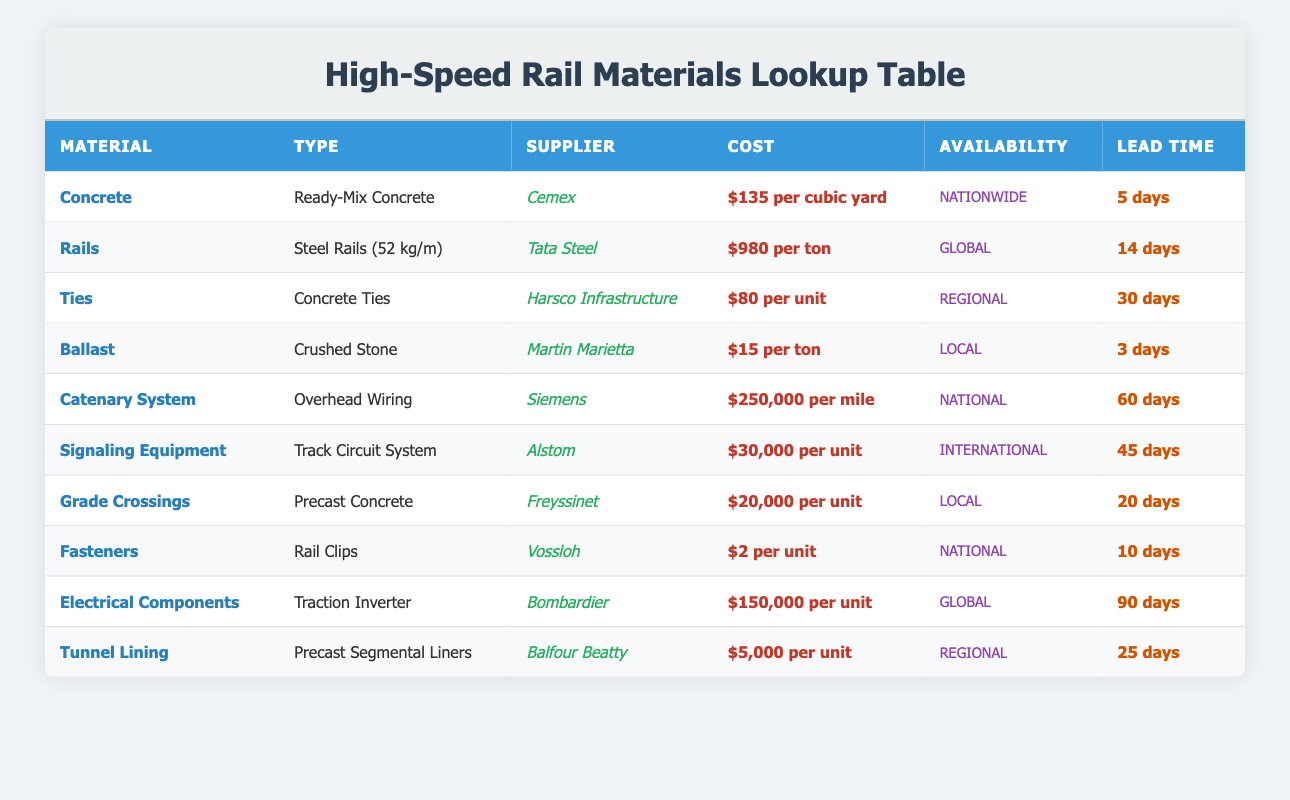What is the cost per cubic yard of Ready-Mix Concrete? The table shows that the cost for Ready-Mix Concrete from Cemex is listed as $135 per cubic yard.
Answer: $135 per cubic yard Which supplier provides Steel Rails? According to the table, the supplier for Steel Rails (52 kg/m) is Tata Steel.
Answer: Tata Steel What is the lead time for Concrete Ties? The lead time for Concrete Ties, as stated in the table, is 30 days.
Answer: 30 days How many materials have a lead time longer than 30 days? By examining the lead times in the table, the Catenary System has a lead time of 60 days and Electrical Components have a lead time of 90 days. This gives us a total of 2 materials with a lead time longer than 30 days.
Answer: 2 What is the total cost for 100 tons of Crushed Stone? The cost for Crushed Stone is $15 per ton. For 100 tons, the total cost would be calculated as 100 × 15 = $1500. Therefore, the total cost for 100 tons of Crushed Stone is $1500.
Answer: $1500 Is the supplier for Signaling Equipment local? The table indicates that the supplier for Signaling Equipment is Alstom, which is categorized as international. Therefore, it is not local.
Answer: No Which material has the longest lead time? The materials' lead times can be compared, and the longest lead time is for Electrical Components, which has 90 days as its lead time.
Answer: Electrical Components What is the total cost of purchasing 10 units of Grade Crossings? The cost for Grade Crossings is $20,000 per unit. To find the total cost for 10 units, we multiply: 10 × 20,000 = 200,000. Therefore, the total cost for 10 units is $200,000.
Answer: $200,000 Are all materials provided by suppliers with national availability? Not all materials have national availability. For instance, materials like Ties and Tunnel Lining are categorized as regional, and Ballast is local. Thus, not all materials have national availability.
Answer: No What is the average cost of materials provided by local suppliers? The local suppliers are Martin Marietta (Ballast, $15 per ton) and Freyssinet (Grade Crossings, $20,000 per unit). To find the average, we first need to convert the cost of Ballast to a comparable form: let's consider a single unit of Ballast for the average. The average cost = (15 + 20,000) / 2 = 10,007.5.
Answer: $10,007.5 